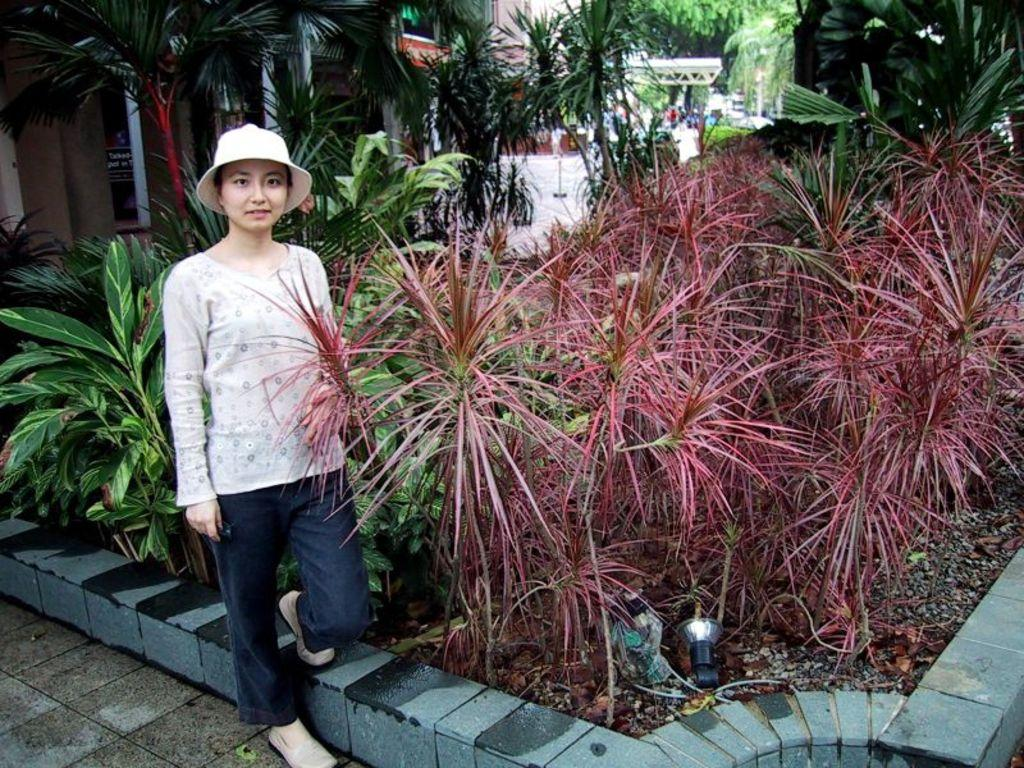Who is present in the image? There is a woman in the image. What is the woman doing in the image? The woman is standing. What is the woman wearing on her head? The woman is wearing a cap. What can be seen in the background of the image? There is a building and trees visible in the background of the image. What is present in the front of the image? There are plants in the front of the image. What type of marble is the woman holding in the image? There is no marble present in the image; the woman is not holding anything. 